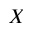<formula> <loc_0><loc_0><loc_500><loc_500>X</formula> 